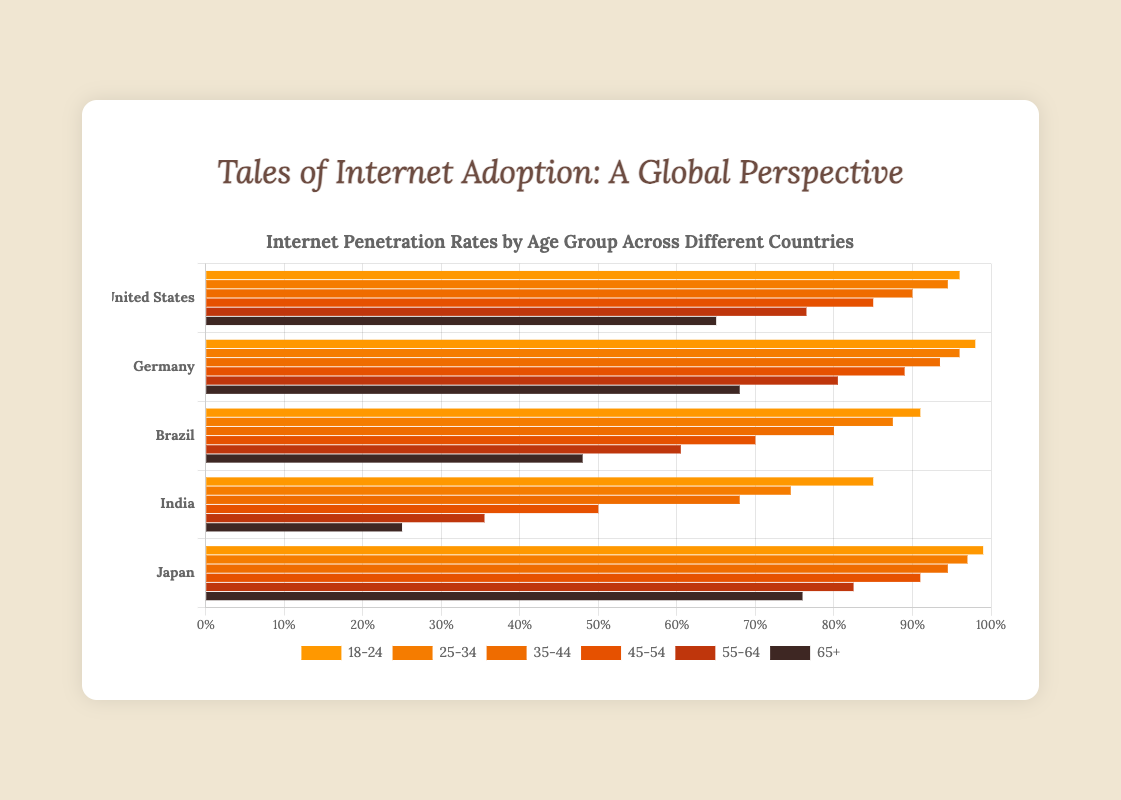Which country has the highest internet penetration rate in the 18-24 age group? By looking at the bar for the 18-24 age group across all countries, we see that Japan has the highest internet penetration rate at 99%.
Answer: Japan Which age group in Germany has the lowest internet penetration rate? Looking at the bars for Germany, the 65+ age group has the lowest internet penetration rate at 68%.
Answer: 65+ What's the difference in the internet penetration rate between the 18-24 age group and the 65+ age group in India? The internet penetration rate for the 18-24 age group in India is 85%, and for the 65+ age group, it's 25%. The difference is 85% - 25% = 60%.
Answer: 60% Which country shows the most significant drop in internet penetration rates from the 18-24 age group to the 25-34 age group? By comparing the drops from the 18-24 age group to the 25-34 age group, India shows the most significant drop, from 85% to 74.5%, which is a 10.5% decrease.
Answer: India Out of all countries, which age group has the smallest range of internet penetration rates? To find the smallest range, we calculate the range for each age group across all countries. The 35-44 age group ranges from 94.5% (Japan) to 68.0% (India), giving a range of 26.5%. The smallest range is for the 65+ age group, ranging from 76% (Japan) to 25% (India), giving a range of 51%. Hence this is incorrect. The correct range is for the 25-34 age group ranging from 97% (Japan) to 74.5% (India), giving a range of 22.5%.
Answer: 25-34 How does the internet penetration rate for the 55-64 age group in Brazil compare to the same age group in Germany? In the 55-64 age group, Brazil has an internet penetration rate of 60.5%, whereas Germany has a rate of 80.5%.
Answer: Germany > Brazil What's the average internet penetration rate across all age groups in the United States? The average rate can be calculated as: (96 + 94.5 + 90 + 85 + 76.5 + 65) / 6 = 507 / 6 = 84.5%.
Answer: 84.5% In which country does the 45-54 age group show the highest internet penetration rate? Looking at the bars for the 45-54 age group, Japan has the highest penetration rate at 91%.
Answer: Japan By comparing Germany and Japan, which country has a higher average internet penetration rate across all age groups? To find the average for Germany: (98 + 96 + 93.5 + 89 + 80.5 + 68) / 6 = 87.17%. For Japan: (99 + 97 + 94.5 + 91 + 82.5 + 76) / 6 = 90.33%. Therefore, Japan has a higher average rate.
Answer: Japan What is the sum of internet penetration rates for all age groups in Brazil? The sum can be found by adding the rates for each age group: 91 + 87.5 + 80 + 70 + 60.5 + 48 = 437.
Answer: 437 